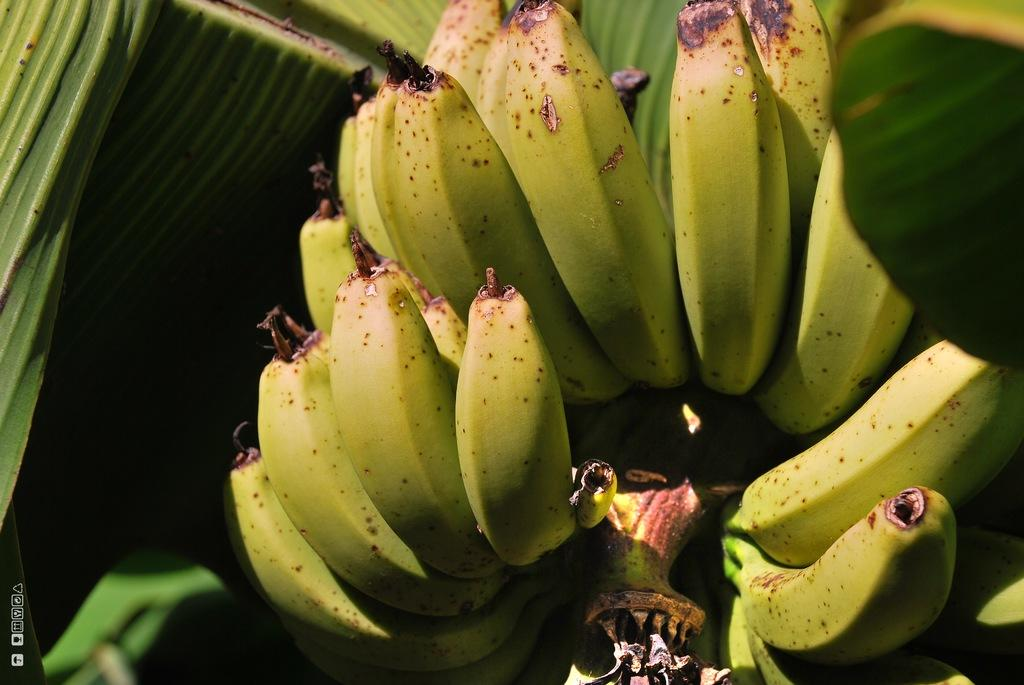What type of vegetation is present in the image? There are leaves in the image. What type of fruit can be seen in the image? There are bananas in the image. What type of chain can be seen connecting the leaves and bananas in the image? There is no chain present in the image, nor is there any connection between the leaves and bananas. Can you tell me which actor is holding the leaves and bananas in the image? There is no actor present in the image, nor is there anyone holding the leaves and bananas. 